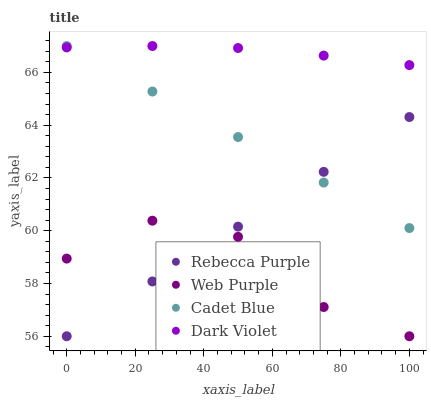Does Web Purple have the minimum area under the curve?
Answer yes or no. Yes. Does Dark Violet have the maximum area under the curve?
Answer yes or no. Yes. Does Cadet Blue have the minimum area under the curve?
Answer yes or no. No. Does Cadet Blue have the maximum area under the curve?
Answer yes or no. No. Is Cadet Blue the smoothest?
Answer yes or no. Yes. Is Web Purple the roughest?
Answer yes or no. Yes. Is Rebecca Purple the smoothest?
Answer yes or no. No. Is Rebecca Purple the roughest?
Answer yes or no. No. Does Web Purple have the lowest value?
Answer yes or no. Yes. Does Cadet Blue have the lowest value?
Answer yes or no. No. Does Dark Violet have the highest value?
Answer yes or no. Yes. Does Rebecca Purple have the highest value?
Answer yes or no. No. Is Web Purple less than Dark Violet?
Answer yes or no. Yes. Is Cadet Blue greater than Web Purple?
Answer yes or no. Yes. Does Dark Violet intersect Cadet Blue?
Answer yes or no. Yes. Is Dark Violet less than Cadet Blue?
Answer yes or no. No. Is Dark Violet greater than Cadet Blue?
Answer yes or no. No. Does Web Purple intersect Dark Violet?
Answer yes or no. No. 